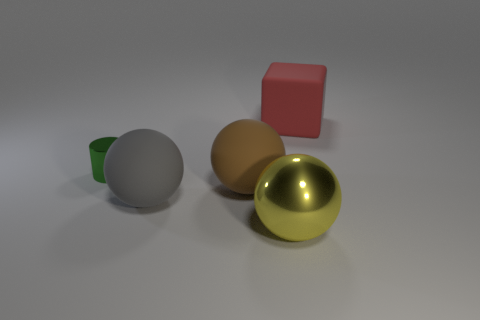Add 2 big red objects. How many objects exist? 7 Subtract all cubes. How many objects are left? 4 Subtract all rubber cubes. Subtract all big rubber blocks. How many objects are left? 3 Add 5 large gray rubber balls. How many large gray rubber balls are left? 6 Add 3 yellow things. How many yellow things exist? 4 Subtract 0 purple blocks. How many objects are left? 5 